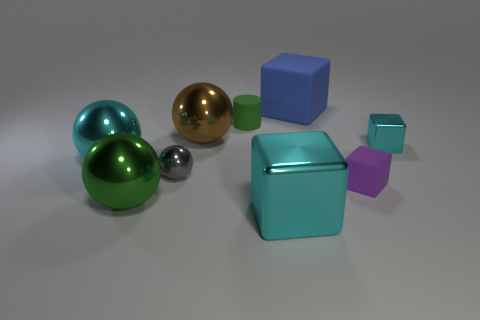If this were the setting for a story, what genre do you think it would fit best? The sterile and organized setup of geometric shapes could lend itself well to a science fiction narrative, perhaps representing an abstract, minimalist future or a virtual reality space where the fundamental elements of reality are being explored or manipulated. 